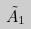Convert formula to latex. <formula><loc_0><loc_0><loc_500><loc_500>\tilde { A } _ { 1 }</formula> 